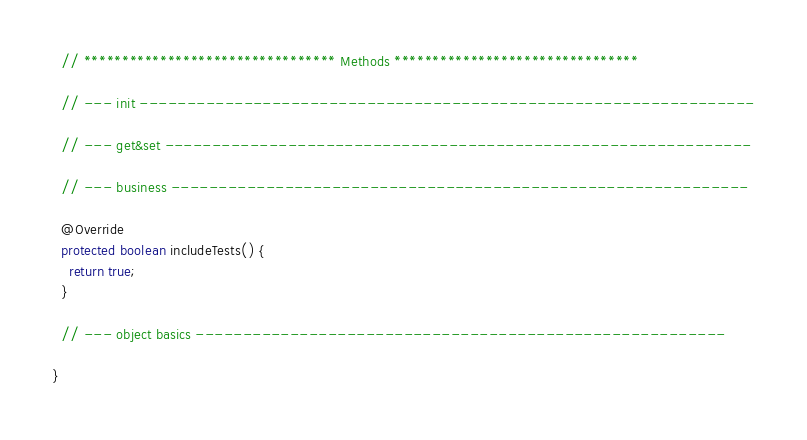Convert code to text. <code><loc_0><loc_0><loc_500><loc_500><_Java_>
  // ********************************* Methods ********************************

  // --- init -----------------------------------------------------------------

  // --- get&set --------------------------------------------------------------

  // --- business -------------------------------------------------------------

  @Override
  protected boolean includeTests() {
    return true;
  }

  // --- object basics --------------------------------------------------------

}
</code> 